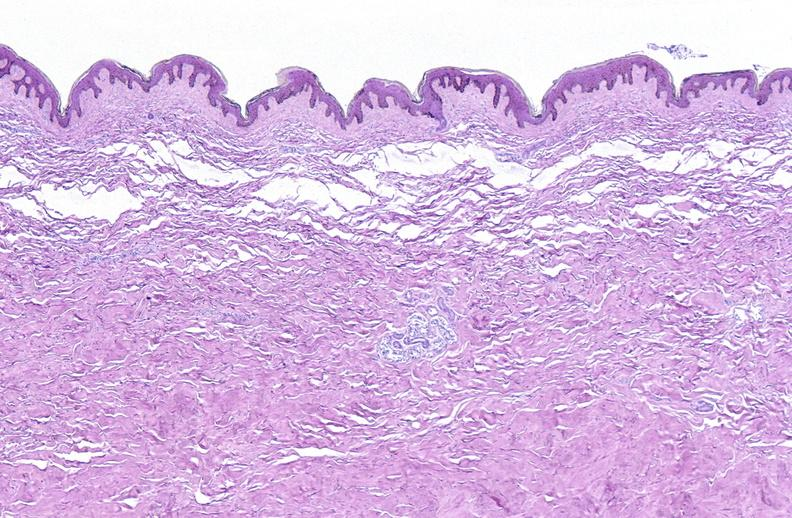where is this?
Answer the question using a single word or phrase. Skin 